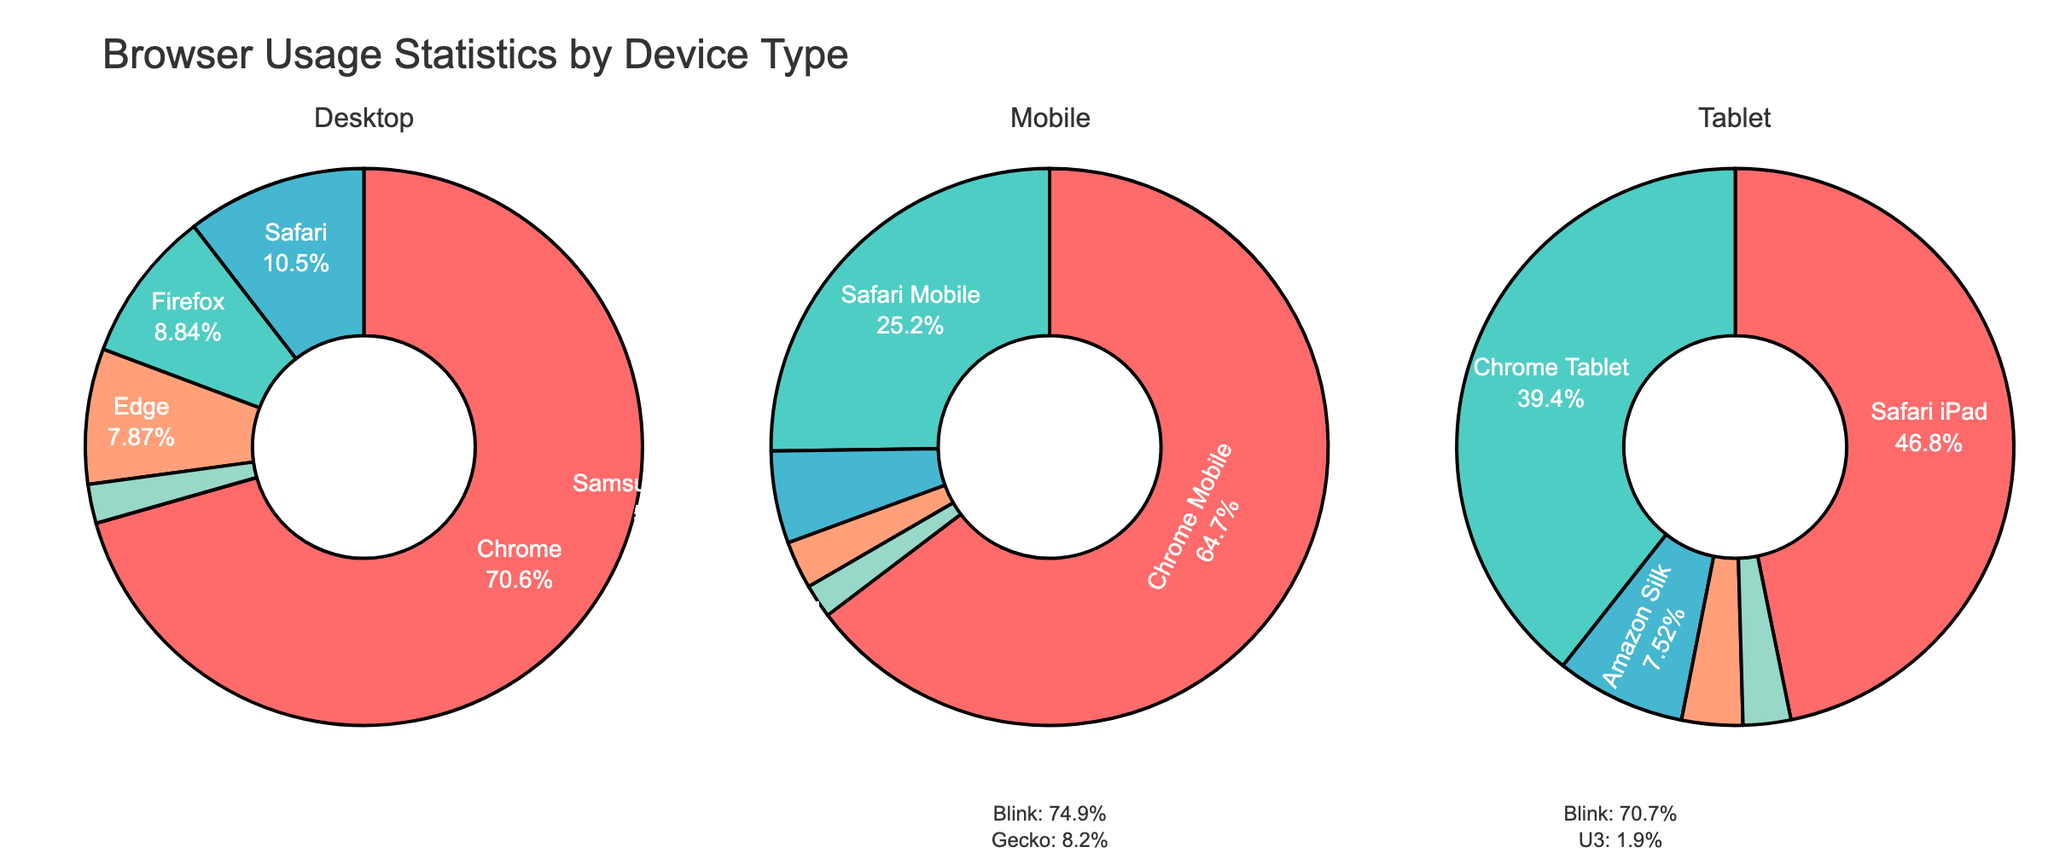What's the title of this figure? The title is located at the top center of the figure, which is usually in a larger and bold font.
Answer: Browser Usage Statistics by Device Type How many browsers are displayed under the 'Tablet' category? In the 'Tablet' category subplot, each slice of the pie chart represents a different browser. Count the distinct labels for browsers.
Answer: 5 Which device type has the highest market share for 'Blink' rendering engine? Look at the annotations below each pie chart and identify which device type has the highest percentage next to 'Blink'. Compare across the three device type annotations.
Answer: Mobile What percentage of the mobile market does 'Safari Mobile' capture? Look at the 'Mobile' pie chart and find the slice labeled 'Safari Mobile'. The percentage should be displayed on the slice.
Answer: 24.5% What's the combined market share of 'Blink' rendering engine across all device types? Sum up the percentages of 'Blink' in the annotations below each pie chart: Desktop, Mobile, and Tablet.
Answer: 65.5% + 62.8% + 2.1% + 35.6% + 6.8% + 2.5% = 175.3% Which browser has the smallest market share in the 'Desktop' category? Look at the 'Desktop' pie chart and find the smallest slice. The label on this slice provides the browser name.
Answer: Opera How does the 'Safari' market share in 'Desktop' compare to 'Safari Mobile' in 'Mobile'? Measure and compare the slices for 'Safari' in 'Desktop' and 'Safari Mobile' in 'Mobile'. Find their market share percentages and compare them.
Answer: 9.7% vs 24.5% Which device type has the pie slice with the largest market share? Examine all three subplots and identify the largest slice across them all. Compare their percentage sizes to find the largest one.
Answer: Desktop (Chrome - 65.5%) 